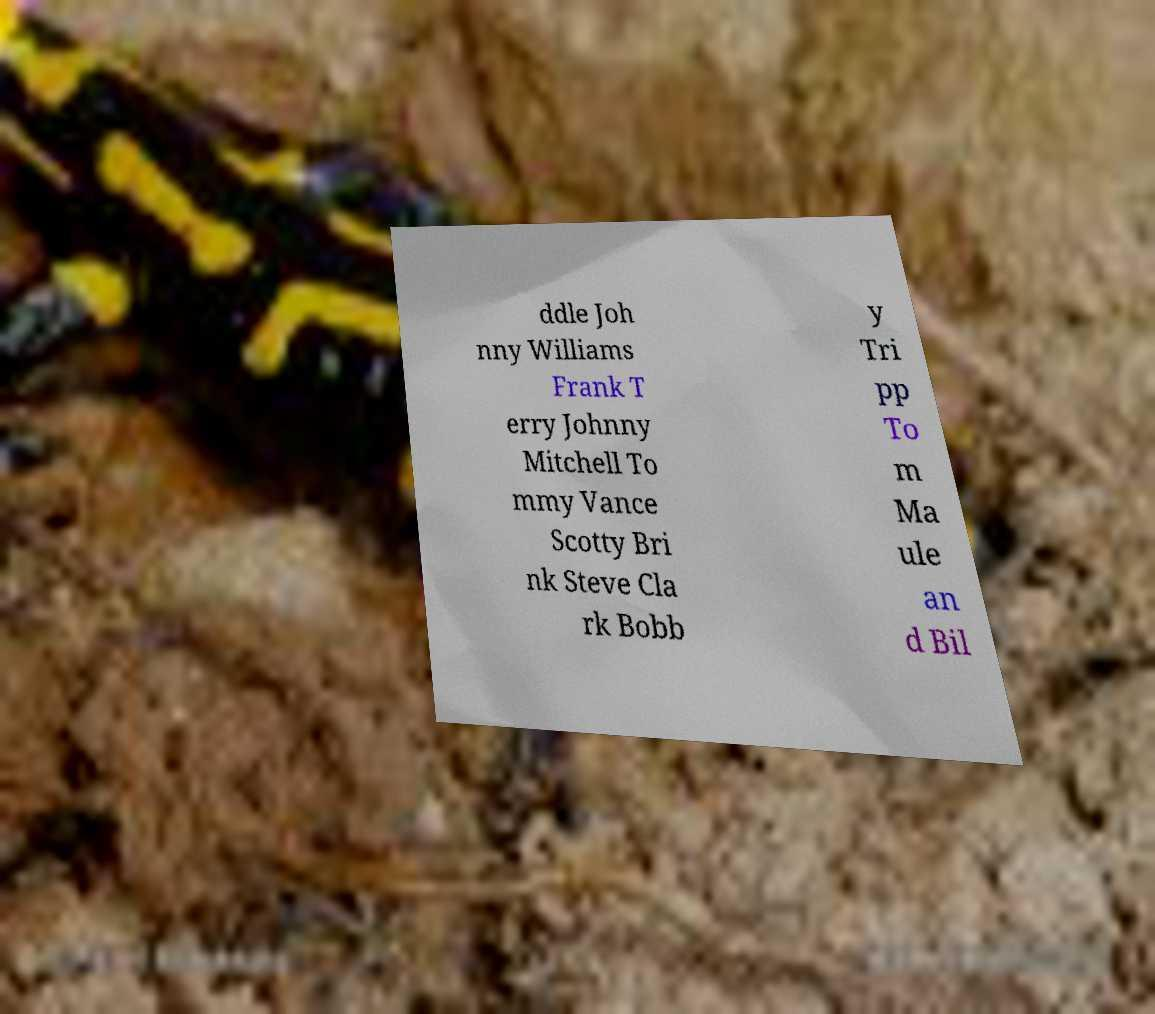There's text embedded in this image that I need extracted. Can you transcribe it verbatim? ddle Joh nny Williams Frank T erry Johnny Mitchell To mmy Vance Scotty Bri nk Steve Cla rk Bobb y Tri pp To m Ma ule an d Bil 